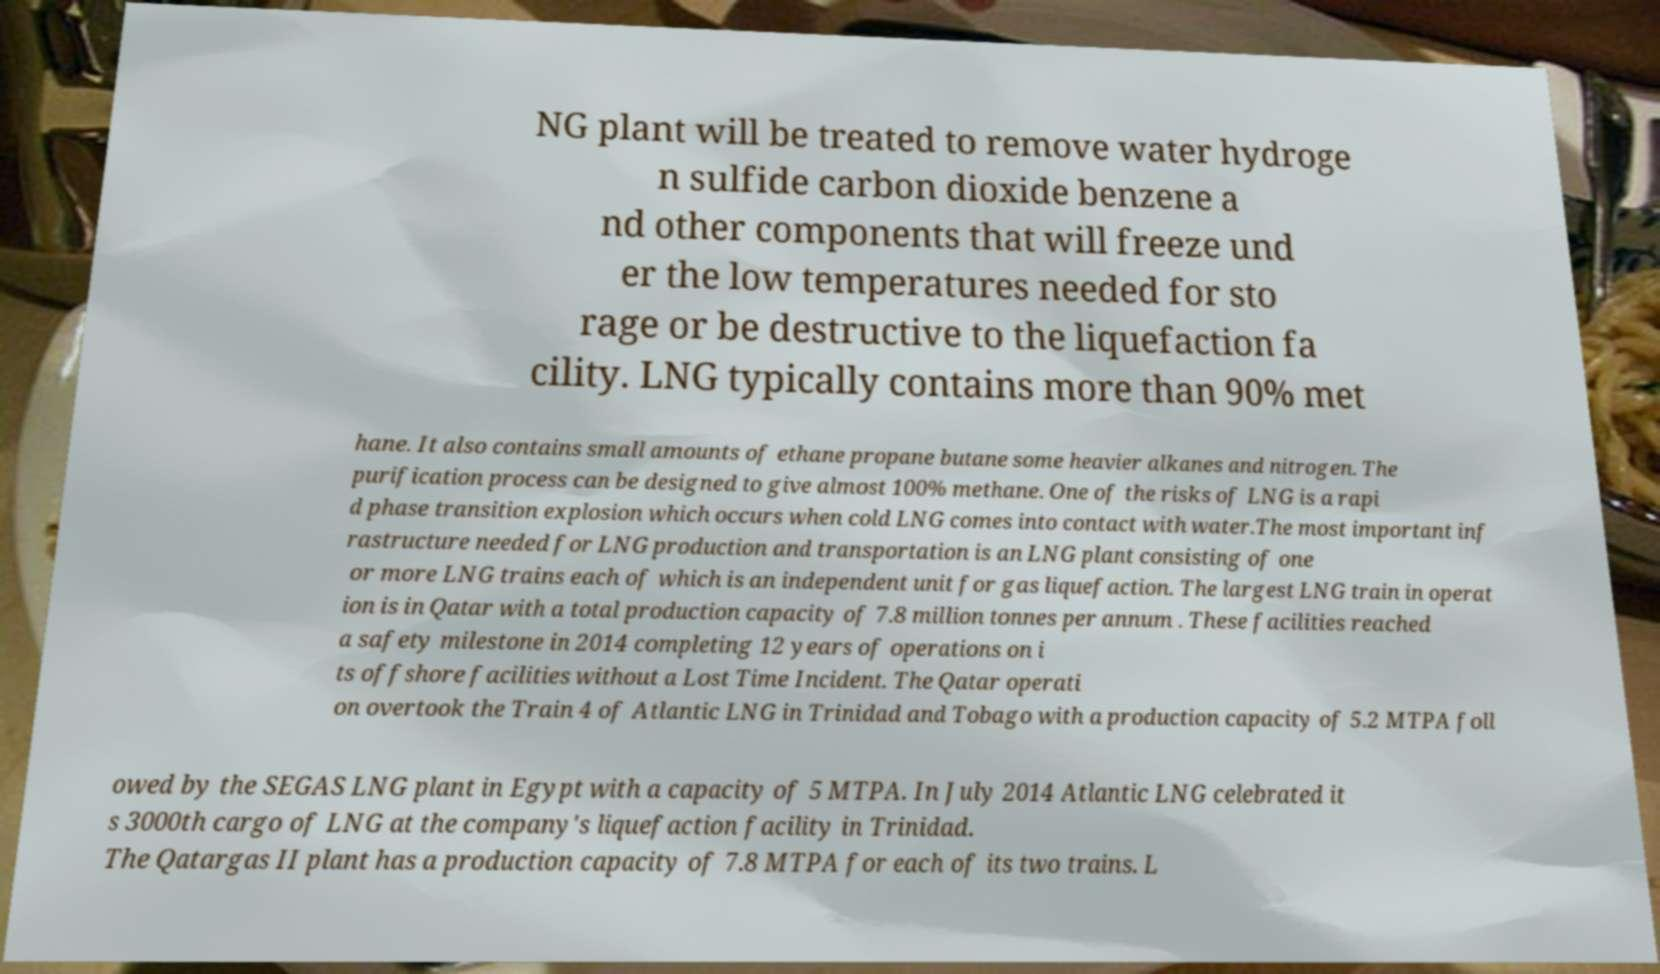Please read and relay the text visible in this image. What does it say? NG plant will be treated to remove water hydroge n sulfide carbon dioxide benzene a nd other components that will freeze und er the low temperatures needed for sto rage or be destructive to the liquefaction fa cility. LNG typically contains more than 90% met hane. It also contains small amounts of ethane propane butane some heavier alkanes and nitrogen. The purification process can be designed to give almost 100% methane. One of the risks of LNG is a rapi d phase transition explosion which occurs when cold LNG comes into contact with water.The most important inf rastructure needed for LNG production and transportation is an LNG plant consisting of one or more LNG trains each of which is an independent unit for gas liquefaction. The largest LNG train in operat ion is in Qatar with a total production capacity of 7.8 million tonnes per annum . These facilities reached a safety milestone in 2014 completing 12 years of operations on i ts offshore facilities without a Lost Time Incident. The Qatar operati on overtook the Train 4 of Atlantic LNG in Trinidad and Tobago with a production capacity of 5.2 MTPA foll owed by the SEGAS LNG plant in Egypt with a capacity of 5 MTPA. In July 2014 Atlantic LNG celebrated it s 3000th cargo of LNG at the company's liquefaction facility in Trinidad. The Qatargas II plant has a production capacity of 7.8 MTPA for each of its two trains. L 